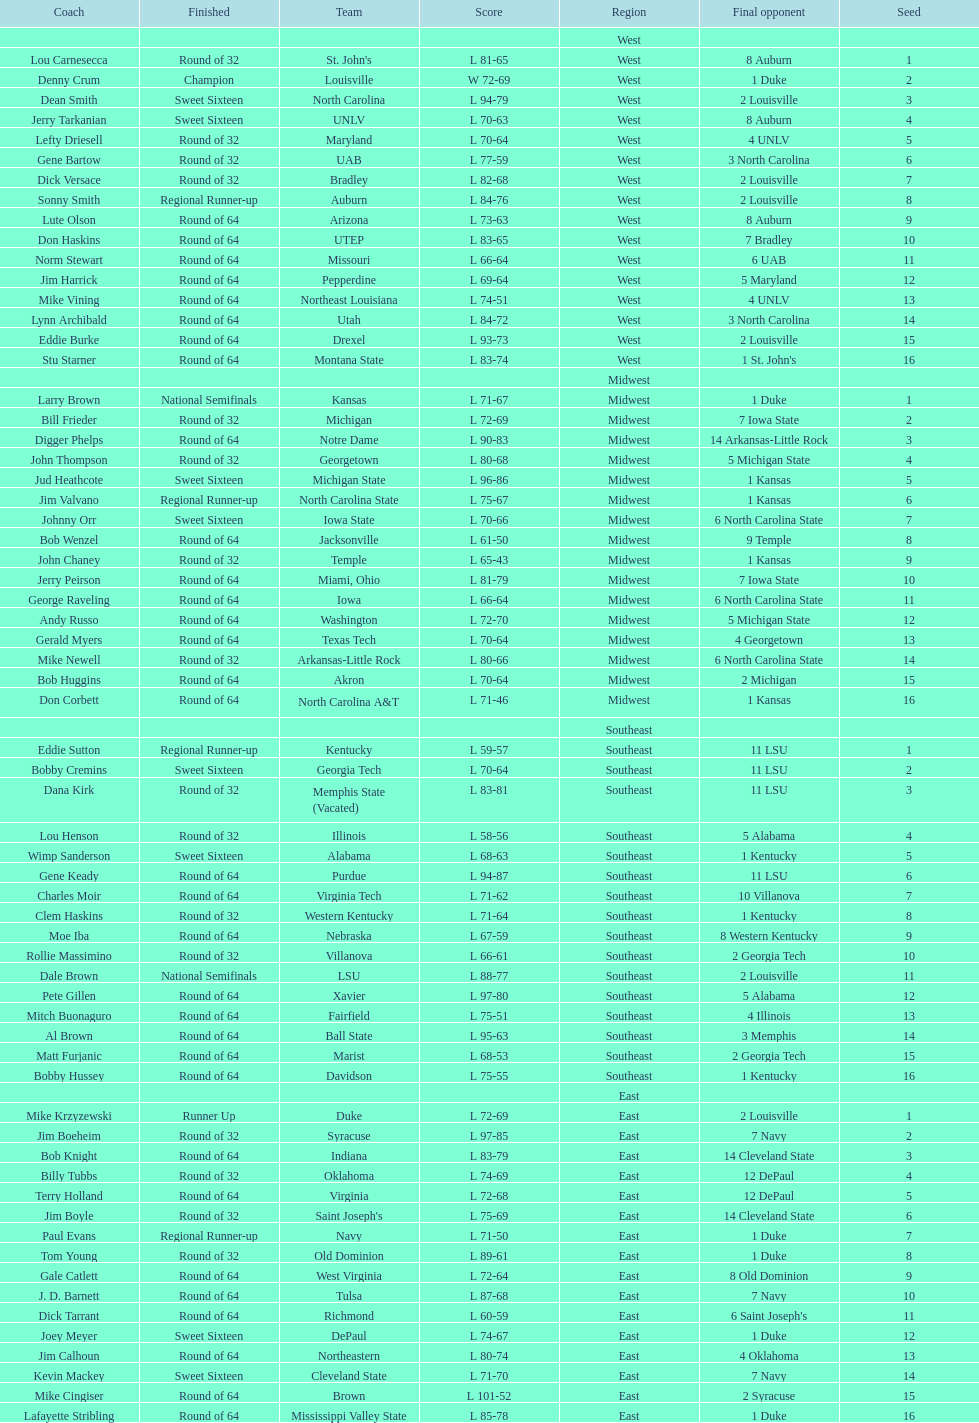Who is the only team from the east region to reach the final round? Duke. 